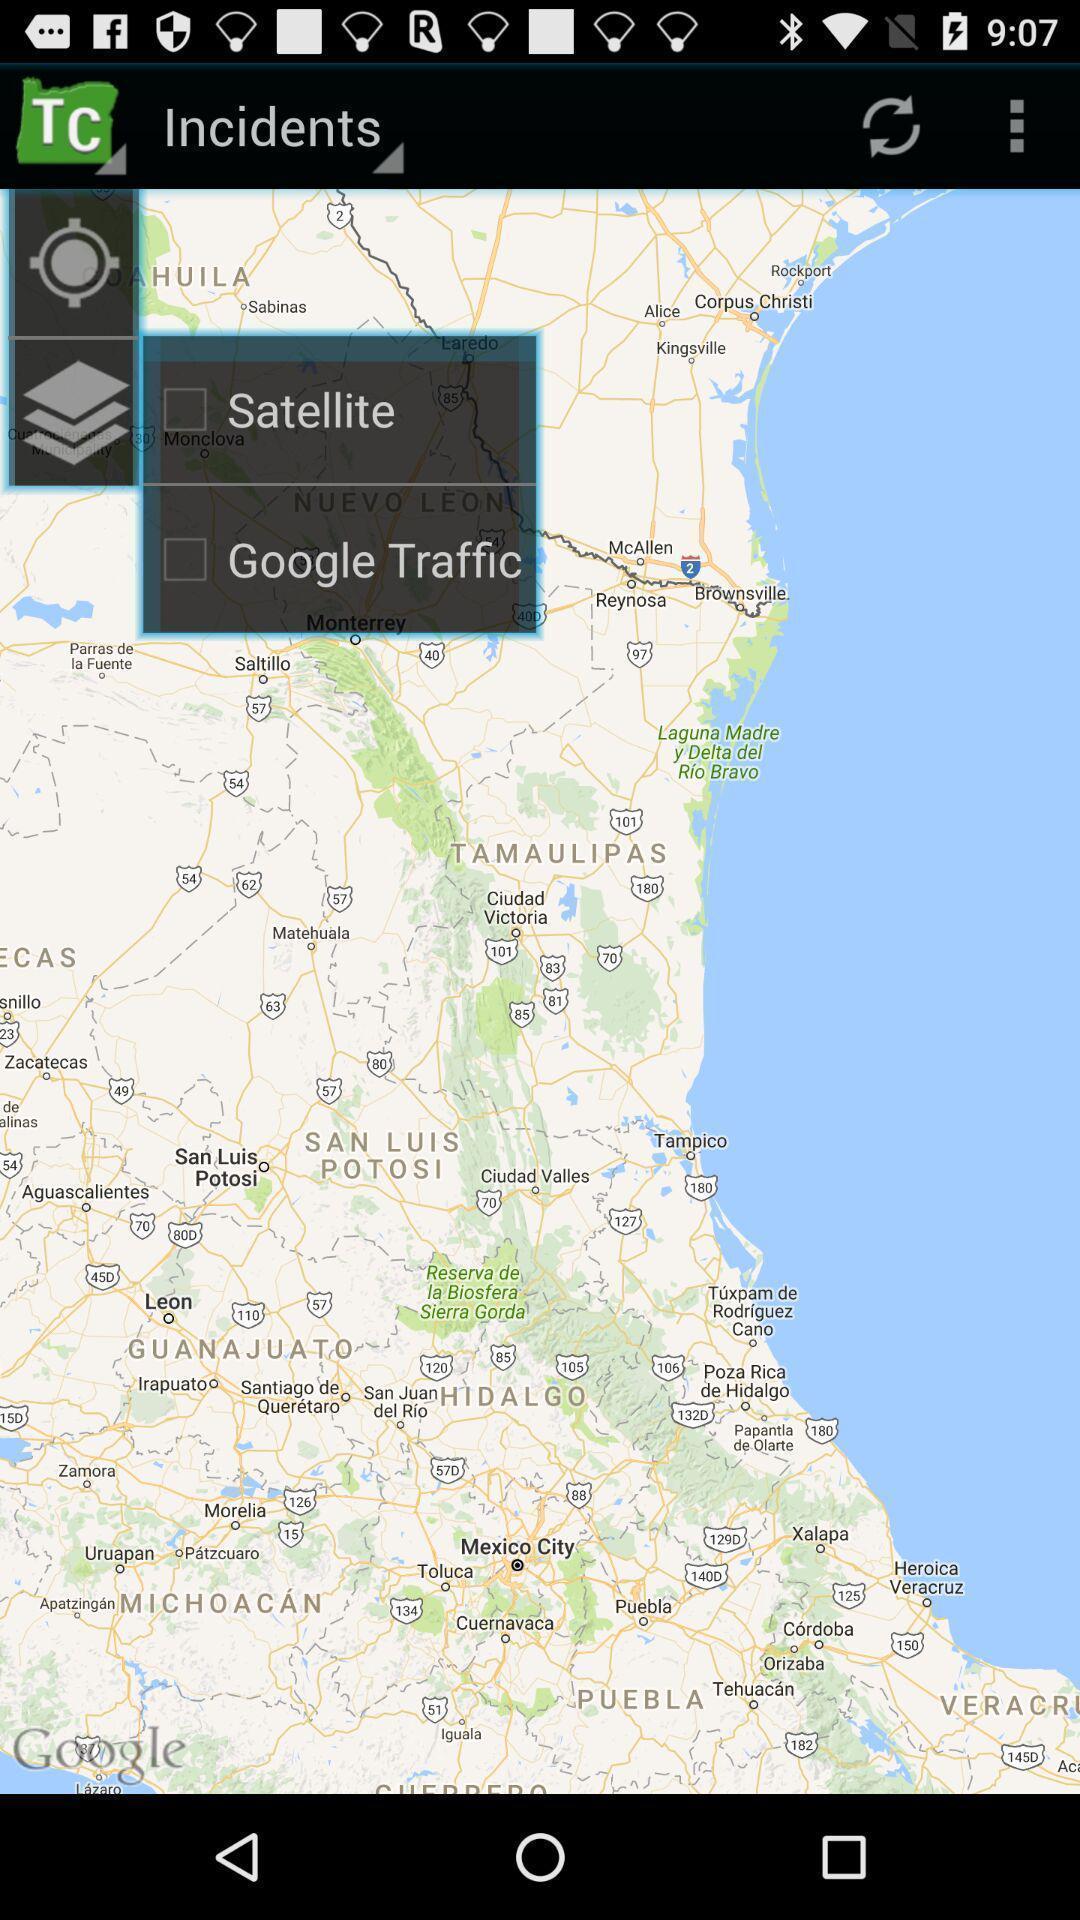Give me a narrative description of this picture. Page showing the google map. 